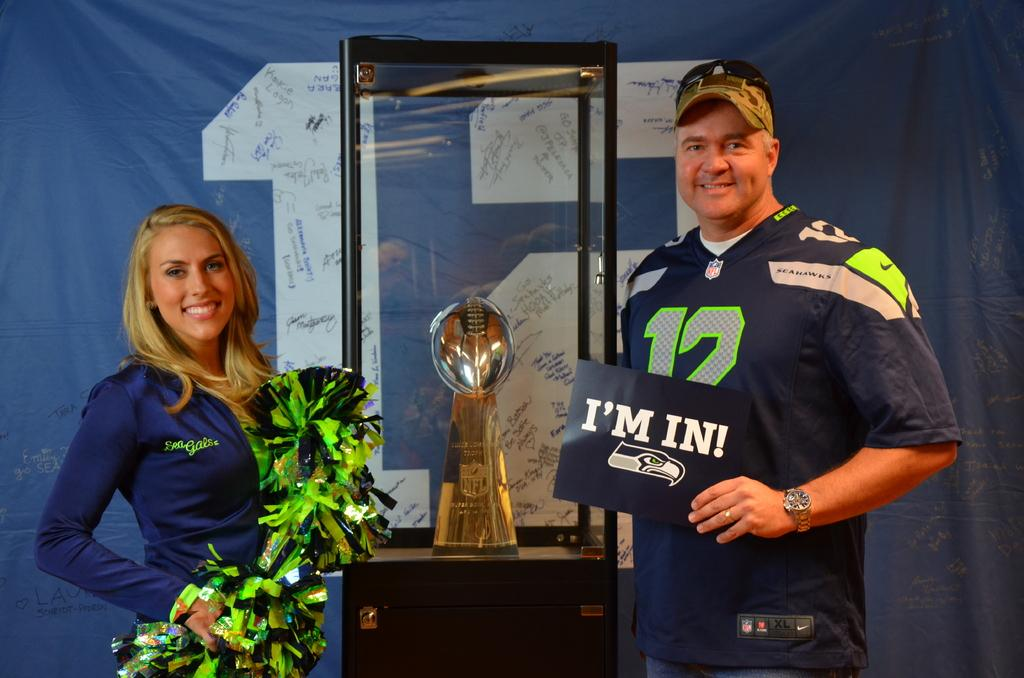<image>
Describe the image concisely. man wearing #12 seahawks jersey holding sign that says i'm in standing next to a blonde woman 